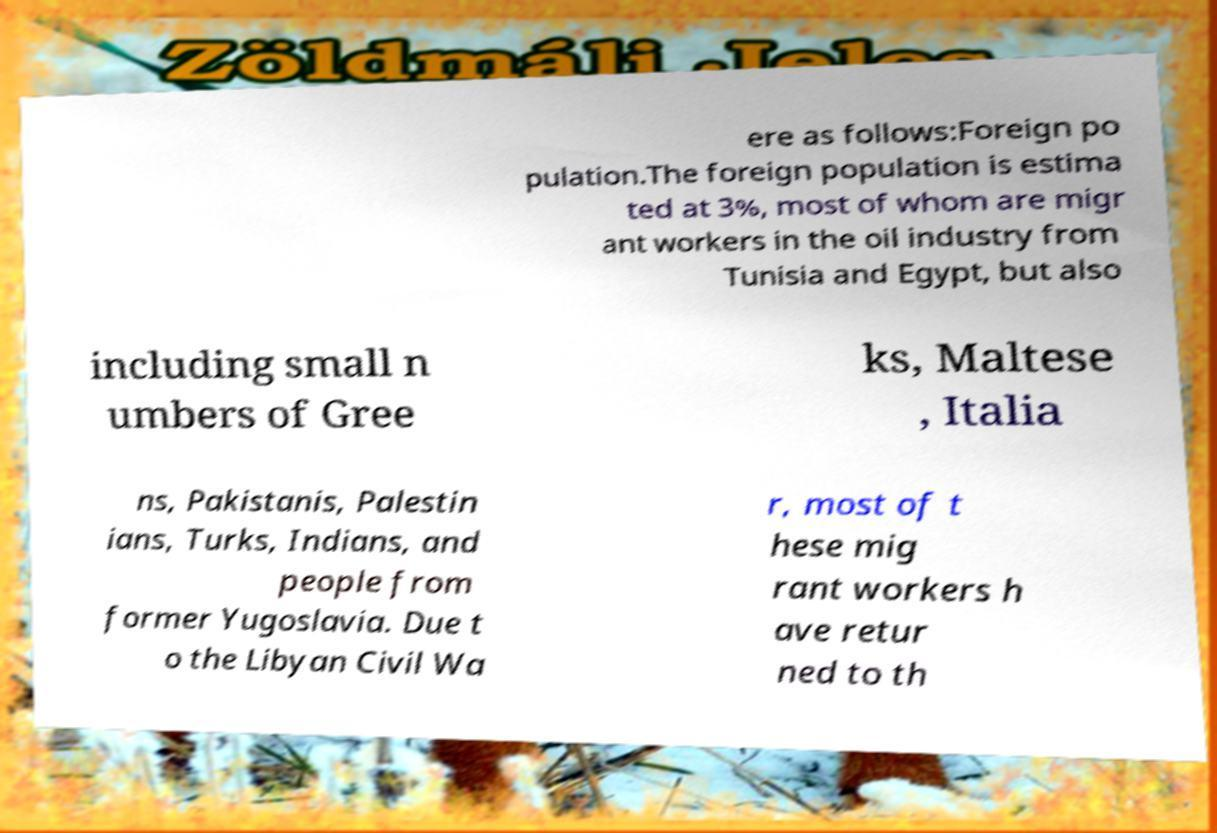I need the written content from this picture converted into text. Can you do that? ere as follows:Foreign po pulation.The foreign population is estima ted at 3%, most of whom are migr ant workers in the oil industry from Tunisia and Egypt, but also including small n umbers of Gree ks, Maltese , Italia ns, Pakistanis, Palestin ians, Turks, Indians, and people from former Yugoslavia. Due t o the Libyan Civil Wa r, most of t hese mig rant workers h ave retur ned to th 